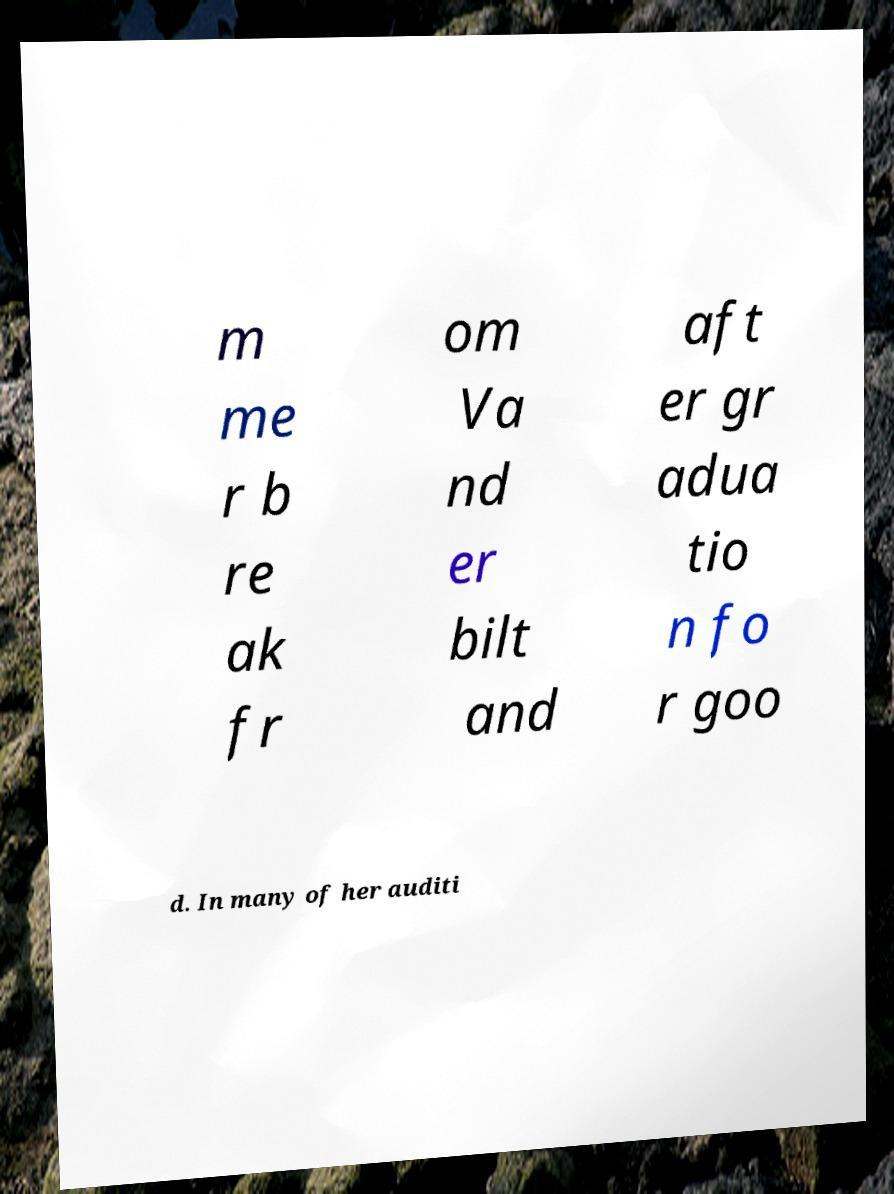I need the written content from this picture converted into text. Can you do that? m me r b re ak fr om Va nd er bilt and aft er gr adua tio n fo r goo d. In many of her auditi 